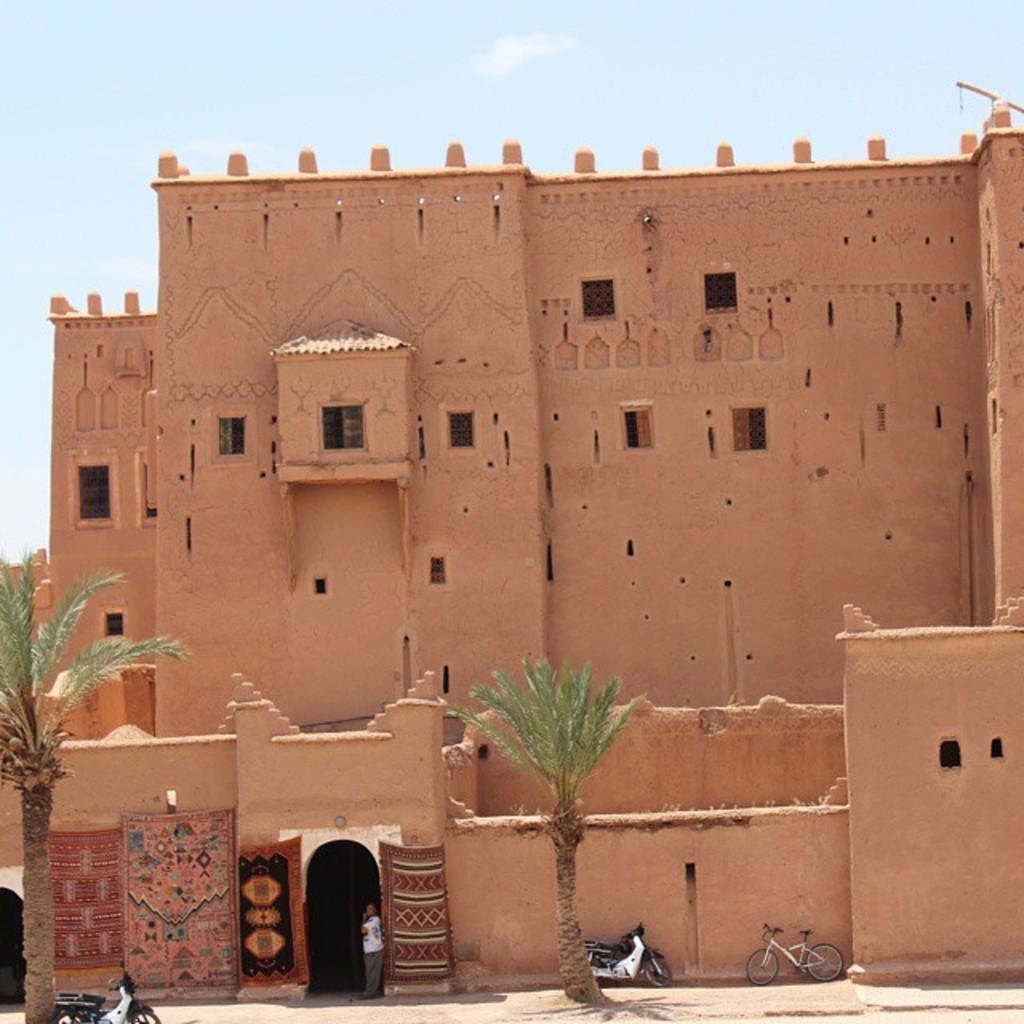Please provide a concise description of this image. In the image we can see the building, pale brown in color. Here we can see a person standing and wearing clothes. Here we can see two wheeler and a bicycle. We can even see the trees and the sky. 